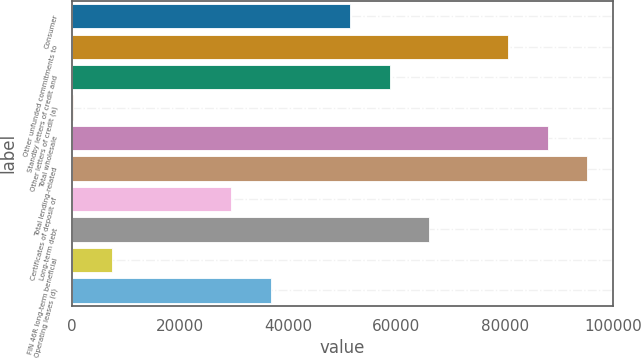Convert chart. <chart><loc_0><loc_0><loc_500><loc_500><bar_chart><fcel>Consumer<fcel>Other unfunded commitments to<fcel>Standby letters of credit and<fcel>Other letters of credit (a)<fcel>Total wholesale<fcel>Total lending-related<fcel>Certificates of deposit of<fcel>Long-term debt<fcel>FIN 46R long-term beneficial<fcel>Operating leases (d)<nl><fcel>51411.1<fcel>80680.3<fcel>58728.4<fcel>190<fcel>87997.6<fcel>95314.9<fcel>29459.2<fcel>66045.7<fcel>7507.3<fcel>36776.5<nl></chart> 